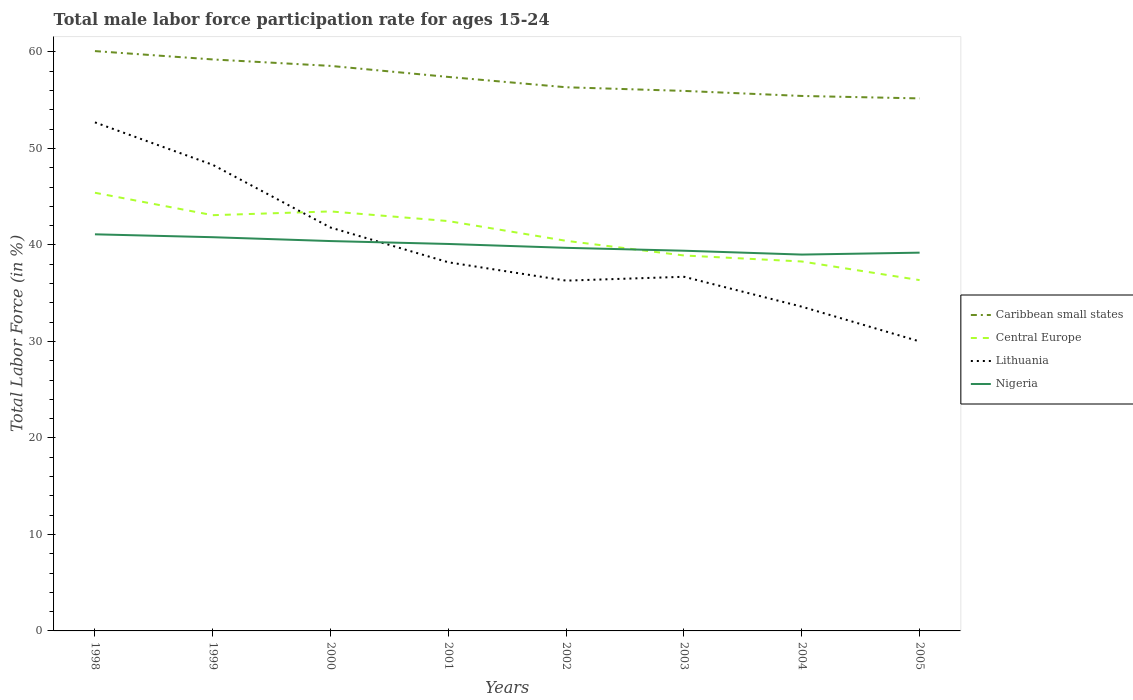Is the number of lines equal to the number of legend labels?
Offer a very short reply. Yes. Across all years, what is the maximum male labor force participation rate in Nigeria?
Your answer should be very brief. 39. In which year was the male labor force participation rate in Central Europe maximum?
Ensure brevity in your answer.  2005. What is the total male labor force participation rate in Caribbean small states in the graph?
Keep it short and to the point. 3.11. What is the difference between the highest and the second highest male labor force participation rate in Central Europe?
Keep it short and to the point. 9.05. Is the male labor force participation rate in Nigeria strictly greater than the male labor force participation rate in Central Europe over the years?
Keep it short and to the point. No. How many lines are there?
Your answer should be compact. 4. What is the difference between two consecutive major ticks on the Y-axis?
Offer a very short reply. 10. Does the graph contain any zero values?
Provide a short and direct response. No. Where does the legend appear in the graph?
Offer a terse response. Center right. What is the title of the graph?
Provide a succinct answer. Total male labor force participation rate for ages 15-24. Does "Rwanda" appear as one of the legend labels in the graph?
Offer a very short reply. No. What is the label or title of the X-axis?
Give a very brief answer. Years. What is the Total Labor Force (in %) of Caribbean small states in 1998?
Offer a very short reply. 60.09. What is the Total Labor Force (in %) in Central Europe in 1998?
Offer a very short reply. 45.41. What is the Total Labor Force (in %) of Lithuania in 1998?
Give a very brief answer. 52.7. What is the Total Labor Force (in %) of Nigeria in 1998?
Your answer should be very brief. 41.1. What is the Total Labor Force (in %) in Caribbean small states in 1999?
Provide a short and direct response. 59.22. What is the Total Labor Force (in %) in Central Europe in 1999?
Keep it short and to the point. 43.08. What is the Total Labor Force (in %) of Lithuania in 1999?
Offer a very short reply. 48.3. What is the Total Labor Force (in %) in Nigeria in 1999?
Your answer should be very brief. 40.8. What is the Total Labor Force (in %) of Caribbean small states in 2000?
Your answer should be very brief. 58.55. What is the Total Labor Force (in %) in Central Europe in 2000?
Make the answer very short. 43.47. What is the Total Labor Force (in %) in Lithuania in 2000?
Ensure brevity in your answer.  41.8. What is the Total Labor Force (in %) in Nigeria in 2000?
Make the answer very short. 40.4. What is the Total Labor Force (in %) in Caribbean small states in 2001?
Provide a short and direct response. 57.41. What is the Total Labor Force (in %) in Central Europe in 2001?
Give a very brief answer. 42.47. What is the Total Labor Force (in %) in Lithuania in 2001?
Offer a terse response. 38.2. What is the Total Labor Force (in %) of Nigeria in 2001?
Provide a succinct answer. 40.1. What is the Total Labor Force (in %) of Caribbean small states in 2002?
Your answer should be very brief. 56.34. What is the Total Labor Force (in %) in Central Europe in 2002?
Your answer should be very brief. 40.42. What is the Total Labor Force (in %) of Lithuania in 2002?
Provide a succinct answer. 36.3. What is the Total Labor Force (in %) in Nigeria in 2002?
Provide a succinct answer. 39.7. What is the Total Labor Force (in %) of Caribbean small states in 2003?
Provide a succinct answer. 55.96. What is the Total Labor Force (in %) in Central Europe in 2003?
Keep it short and to the point. 38.91. What is the Total Labor Force (in %) in Lithuania in 2003?
Offer a terse response. 36.7. What is the Total Labor Force (in %) of Nigeria in 2003?
Ensure brevity in your answer.  39.4. What is the Total Labor Force (in %) in Caribbean small states in 2004?
Make the answer very short. 55.44. What is the Total Labor Force (in %) of Central Europe in 2004?
Provide a succinct answer. 38.28. What is the Total Labor Force (in %) in Lithuania in 2004?
Give a very brief answer. 33.6. What is the Total Labor Force (in %) of Caribbean small states in 2005?
Make the answer very short. 55.18. What is the Total Labor Force (in %) in Central Europe in 2005?
Offer a terse response. 36.35. What is the Total Labor Force (in %) of Nigeria in 2005?
Ensure brevity in your answer.  39.2. Across all years, what is the maximum Total Labor Force (in %) in Caribbean small states?
Offer a very short reply. 60.09. Across all years, what is the maximum Total Labor Force (in %) of Central Europe?
Offer a very short reply. 45.41. Across all years, what is the maximum Total Labor Force (in %) of Lithuania?
Make the answer very short. 52.7. Across all years, what is the maximum Total Labor Force (in %) of Nigeria?
Your response must be concise. 41.1. Across all years, what is the minimum Total Labor Force (in %) in Caribbean small states?
Keep it short and to the point. 55.18. Across all years, what is the minimum Total Labor Force (in %) in Central Europe?
Offer a very short reply. 36.35. Across all years, what is the minimum Total Labor Force (in %) in Nigeria?
Your answer should be very brief. 39. What is the total Total Labor Force (in %) in Caribbean small states in the graph?
Provide a succinct answer. 458.19. What is the total Total Labor Force (in %) in Central Europe in the graph?
Provide a short and direct response. 328.4. What is the total Total Labor Force (in %) in Lithuania in the graph?
Offer a terse response. 317.6. What is the total Total Labor Force (in %) of Nigeria in the graph?
Make the answer very short. 319.7. What is the difference between the Total Labor Force (in %) in Caribbean small states in 1998 and that in 1999?
Provide a short and direct response. 0.87. What is the difference between the Total Labor Force (in %) of Central Europe in 1998 and that in 1999?
Ensure brevity in your answer.  2.32. What is the difference between the Total Labor Force (in %) in Caribbean small states in 1998 and that in 2000?
Your response must be concise. 1.53. What is the difference between the Total Labor Force (in %) in Central Europe in 1998 and that in 2000?
Offer a terse response. 1.93. What is the difference between the Total Labor Force (in %) in Lithuania in 1998 and that in 2000?
Offer a terse response. 10.9. What is the difference between the Total Labor Force (in %) of Nigeria in 1998 and that in 2000?
Offer a very short reply. 0.7. What is the difference between the Total Labor Force (in %) of Caribbean small states in 1998 and that in 2001?
Make the answer very short. 2.68. What is the difference between the Total Labor Force (in %) of Central Europe in 1998 and that in 2001?
Ensure brevity in your answer.  2.94. What is the difference between the Total Labor Force (in %) in Nigeria in 1998 and that in 2001?
Provide a short and direct response. 1. What is the difference between the Total Labor Force (in %) in Caribbean small states in 1998 and that in 2002?
Give a very brief answer. 3.75. What is the difference between the Total Labor Force (in %) in Central Europe in 1998 and that in 2002?
Offer a terse response. 4.98. What is the difference between the Total Labor Force (in %) in Caribbean small states in 1998 and that in 2003?
Ensure brevity in your answer.  4.13. What is the difference between the Total Labor Force (in %) in Central Europe in 1998 and that in 2003?
Offer a very short reply. 6.5. What is the difference between the Total Labor Force (in %) of Caribbean small states in 1998 and that in 2004?
Provide a short and direct response. 4.65. What is the difference between the Total Labor Force (in %) in Central Europe in 1998 and that in 2004?
Provide a short and direct response. 7.12. What is the difference between the Total Labor Force (in %) of Caribbean small states in 1998 and that in 2005?
Make the answer very short. 4.9. What is the difference between the Total Labor Force (in %) of Central Europe in 1998 and that in 2005?
Your answer should be compact. 9.05. What is the difference between the Total Labor Force (in %) of Lithuania in 1998 and that in 2005?
Provide a succinct answer. 22.7. What is the difference between the Total Labor Force (in %) in Caribbean small states in 1999 and that in 2000?
Offer a very short reply. 0.67. What is the difference between the Total Labor Force (in %) in Central Europe in 1999 and that in 2000?
Your response must be concise. -0.39. What is the difference between the Total Labor Force (in %) of Lithuania in 1999 and that in 2000?
Your response must be concise. 6.5. What is the difference between the Total Labor Force (in %) of Nigeria in 1999 and that in 2000?
Provide a short and direct response. 0.4. What is the difference between the Total Labor Force (in %) in Caribbean small states in 1999 and that in 2001?
Your answer should be very brief. 1.81. What is the difference between the Total Labor Force (in %) in Central Europe in 1999 and that in 2001?
Offer a terse response. 0.61. What is the difference between the Total Labor Force (in %) of Caribbean small states in 1999 and that in 2002?
Make the answer very short. 2.88. What is the difference between the Total Labor Force (in %) in Central Europe in 1999 and that in 2002?
Your answer should be very brief. 2.66. What is the difference between the Total Labor Force (in %) in Nigeria in 1999 and that in 2002?
Your response must be concise. 1.1. What is the difference between the Total Labor Force (in %) in Caribbean small states in 1999 and that in 2003?
Your response must be concise. 3.26. What is the difference between the Total Labor Force (in %) in Central Europe in 1999 and that in 2003?
Provide a succinct answer. 4.18. What is the difference between the Total Labor Force (in %) in Lithuania in 1999 and that in 2003?
Offer a very short reply. 11.6. What is the difference between the Total Labor Force (in %) in Caribbean small states in 1999 and that in 2004?
Provide a short and direct response. 3.78. What is the difference between the Total Labor Force (in %) in Central Europe in 1999 and that in 2004?
Offer a terse response. 4.8. What is the difference between the Total Labor Force (in %) of Lithuania in 1999 and that in 2004?
Provide a short and direct response. 14.7. What is the difference between the Total Labor Force (in %) of Caribbean small states in 1999 and that in 2005?
Keep it short and to the point. 4.04. What is the difference between the Total Labor Force (in %) of Central Europe in 1999 and that in 2005?
Provide a short and direct response. 6.73. What is the difference between the Total Labor Force (in %) in Lithuania in 1999 and that in 2005?
Make the answer very short. 18.3. What is the difference between the Total Labor Force (in %) of Nigeria in 1999 and that in 2005?
Your answer should be compact. 1.6. What is the difference between the Total Labor Force (in %) in Caribbean small states in 2000 and that in 2001?
Give a very brief answer. 1.14. What is the difference between the Total Labor Force (in %) in Nigeria in 2000 and that in 2001?
Give a very brief answer. 0.3. What is the difference between the Total Labor Force (in %) of Caribbean small states in 2000 and that in 2002?
Your answer should be very brief. 2.21. What is the difference between the Total Labor Force (in %) of Central Europe in 2000 and that in 2002?
Make the answer very short. 3.05. What is the difference between the Total Labor Force (in %) in Lithuania in 2000 and that in 2002?
Provide a short and direct response. 5.5. What is the difference between the Total Labor Force (in %) in Nigeria in 2000 and that in 2002?
Provide a succinct answer. 0.7. What is the difference between the Total Labor Force (in %) in Caribbean small states in 2000 and that in 2003?
Your answer should be very brief. 2.59. What is the difference between the Total Labor Force (in %) in Central Europe in 2000 and that in 2003?
Keep it short and to the point. 4.57. What is the difference between the Total Labor Force (in %) in Lithuania in 2000 and that in 2003?
Your response must be concise. 5.1. What is the difference between the Total Labor Force (in %) of Caribbean small states in 2000 and that in 2004?
Offer a terse response. 3.11. What is the difference between the Total Labor Force (in %) of Central Europe in 2000 and that in 2004?
Provide a succinct answer. 5.19. What is the difference between the Total Labor Force (in %) in Lithuania in 2000 and that in 2004?
Your answer should be compact. 8.2. What is the difference between the Total Labor Force (in %) of Caribbean small states in 2000 and that in 2005?
Offer a terse response. 3.37. What is the difference between the Total Labor Force (in %) of Central Europe in 2000 and that in 2005?
Ensure brevity in your answer.  7.12. What is the difference between the Total Labor Force (in %) of Lithuania in 2000 and that in 2005?
Your answer should be very brief. 11.8. What is the difference between the Total Labor Force (in %) of Nigeria in 2000 and that in 2005?
Offer a very short reply. 1.2. What is the difference between the Total Labor Force (in %) in Caribbean small states in 2001 and that in 2002?
Make the answer very short. 1.07. What is the difference between the Total Labor Force (in %) in Central Europe in 2001 and that in 2002?
Offer a terse response. 2.05. What is the difference between the Total Labor Force (in %) of Lithuania in 2001 and that in 2002?
Provide a succinct answer. 1.9. What is the difference between the Total Labor Force (in %) in Caribbean small states in 2001 and that in 2003?
Ensure brevity in your answer.  1.45. What is the difference between the Total Labor Force (in %) of Central Europe in 2001 and that in 2003?
Your answer should be very brief. 3.56. What is the difference between the Total Labor Force (in %) of Nigeria in 2001 and that in 2003?
Provide a succinct answer. 0.7. What is the difference between the Total Labor Force (in %) of Caribbean small states in 2001 and that in 2004?
Offer a very short reply. 1.97. What is the difference between the Total Labor Force (in %) of Central Europe in 2001 and that in 2004?
Keep it short and to the point. 4.19. What is the difference between the Total Labor Force (in %) in Lithuania in 2001 and that in 2004?
Ensure brevity in your answer.  4.6. What is the difference between the Total Labor Force (in %) in Nigeria in 2001 and that in 2004?
Make the answer very short. 1.1. What is the difference between the Total Labor Force (in %) of Caribbean small states in 2001 and that in 2005?
Give a very brief answer. 2.22. What is the difference between the Total Labor Force (in %) in Central Europe in 2001 and that in 2005?
Offer a very short reply. 6.12. What is the difference between the Total Labor Force (in %) of Caribbean small states in 2002 and that in 2003?
Your answer should be very brief. 0.38. What is the difference between the Total Labor Force (in %) of Central Europe in 2002 and that in 2003?
Provide a succinct answer. 1.52. What is the difference between the Total Labor Force (in %) in Nigeria in 2002 and that in 2003?
Keep it short and to the point. 0.3. What is the difference between the Total Labor Force (in %) of Caribbean small states in 2002 and that in 2004?
Ensure brevity in your answer.  0.9. What is the difference between the Total Labor Force (in %) in Central Europe in 2002 and that in 2004?
Give a very brief answer. 2.14. What is the difference between the Total Labor Force (in %) in Lithuania in 2002 and that in 2004?
Give a very brief answer. 2.7. What is the difference between the Total Labor Force (in %) in Nigeria in 2002 and that in 2004?
Give a very brief answer. 0.7. What is the difference between the Total Labor Force (in %) in Caribbean small states in 2002 and that in 2005?
Ensure brevity in your answer.  1.15. What is the difference between the Total Labor Force (in %) in Central Europe in 2002 and that in 2005?
Offer a terse response. 4.07. What is the difference between the Total Labor Force (in %) of Lithuania in 2002 and that in 2005?
Offer a very short reply. 6.3. What is the difference between the Total Labor Force (in %) in Caribbean small states in 2003 and that in 2004?
Ensure brevity in your answer.  0.52. What is the difference between the Total Labor Force (in %) of Central Europe in 2003 and that in 2004?
Provide a short and direct response. 0.62. What is the difference between the Total Labor Force (in %) in Lithuania in 2003 and that in 2004?
Give a very brief answer. 3.1. What is the difference between the Total Labor Force (in %) in Caribbean small states in 2003 and that in 2005?
Your answer should be very brief. 0.78. What is the difference between the Total Labor Force (in %) in Central Europe in 2003 and that in 2005?
Keep it short and to the point. 2.55. What is the difference between the Total Labor Force (in %) of Lithuania in 2003 and that in 2005?
Provide a succinct answer. 6.7. What is the difference between the Total Labor Force (in %) of Caribbean small states in 2004 and that in 2005?
Keep it short and to the point. 0.25. What is the difference between the Total Labor Force (in %) of Central Europe in 2004 and that in 2005?
Make the answer very short. 1.93. What is the difference between the Total Labor Force (in %) of Nigeria in 2004 and that in 2005?
Your answer should be very brief. -0.2. What is the difference between the Total Labor Force (in %) of Caribbean small states in 1998 and the Total Labor Force (in %) of Central Europe in 1999?
Keep it short and to the point. 17. What is the difference between the Total Labor Force (in %) in Caribbean small states in 1998 and the Total Labor Force (in %) in Lithuania in 1999?
Your answer should be compact. 11.79. What is the difference between the Total Labor Force (in %) of Caribbean small states in 1998 and the Total Labor Force (in %) of Nigeria in 1999?
Your answer should be compact. 19.29. What is the difference between the Total Labor Force (in %) of Central Europe in 1998 and the Total Labor Force (in %) of Lithuania in 1999?
Ensure brevity in your answer.  -2.89. What is the difference between the Total Labor Force (in %) in Central Europe in 1998 and the Total Labor Force (in %) in Nigeria in 1999?
Your answer should be very brief. 4.61. What is the difference between the Total Labor Force (in %) in Caribbean small states in 1998 and the Total Labor Force (in %) in Central Europe in 2000?
Provide a succinct answer. 16.61. What is the difference between the Total Labor Force (in %) in Caribbean small states in 1998 and the Total Labor Force (in %) in Lithuania in 2000?
Provide a short and direct response. 18.29. What is the difference between the Total Labor Force (in %) in Caribbean small states in 1998 and the Total Labor Force (in %) in Nigeria in 2000?
Your answer should be compact. 19.69. What is the difference between the Total Labor Force (in %) of Central Europe in 1998 and the Total Labor Force (in %) of Lithuania in 2000?
Ensure brevity in your answer.  3.61. What is the difference between the Total Labor Force (in %) of Central Europe in 1998 and the Total Labor Force (in %) of Nigeria in 2000?
Offer a very short reply. 5.01. What is the difference between the Total Labor Force (in %) in Lithuania in 1998 and the Total Labor Force (in %) in Nigeria in 2000?
Provide a short and direct response. 12.3. What is the difference between the Total Labor Force (in %) of Caribbean small states in 1998 and the Total Labor Force (in %) of Central Europe in 2001?
Make the answer very short. 17.62. What is the difference between the Total Labor Force (in %) of Caribbean small states in 1998 and the Total Labor Force (in %) of Lithuania in 2001?
Make the answer very short. 21.89. What is the difference between the Total Labor Force (in %) of Caribbean small states in 1998 and the Total Labor Force (in %) of Nigeria in 2001?
Your answer should be very brief. 19.99. What is the difference between the Total Labor Force (in %) of Central Europe in 1998 and the Total Labor Force (in %) of Lithuania in 2001?
Your answer should be compact. 7.21. What is the difference between the Total Labor Force (in %) in Central Europe in 1998 and the Total Labor Force (in %) in Nigeria in 2001?
Give a very brief answer. 5.31. What is the difference between the Total Labor Force (in %) of Caribbean small states in 1998 and the Total Labor Force (in %) of Central Europe in 2002?
Your response must be concise. 19.66. What is the difference between the Total Labor Force (in %) of Caribbean small states in 1998 and the Total Labor Force (in %) of Lithuania in 2002?
Provide a short and direct response. 23.79. What is the difference between the Total Labor Force (in %) of Caribbean small states in 1998 and the Total Labor Force (in %) of Nigeria in 2002?
Ensure brevity in your answer.  20.39. What is the difference between the Total Labor Force (in %) in Central Europe in 1998 and the Total Labor Force (in %) in Lithuania in 2002?
Offer a very short reply. 9.11. What is the difference between the Total Labor Force (in %) in Central Europe in 1998 and the Total Labor Force (in %) in Nigeria in 2002?
Provide a succinct answer. 5.71. What is the difference between the Total Labor Force (in %) of Caribbean small states in 1998 and the Total Labor Force (in %) of Central Europe in 2003?
Provide a short and direct response. 21.18. What is the difference between the Total Labor Force (in %) of Caribbean small states in 1998 and the Total Labor Force (in %) of Lithuania in 2003?
Your answer should be very brief. 23.39. What is the difference between the Total Labor Force (in %) in Caribbean small states in 1998 and the Total Labor Force (in %) in Nigeria in 2003?
Ensure brevity in your answer.  20.69. What is the difference between the Total Labor Force (in %) of Central Europe in 1998 and the Total Labor Force (in %) of Lithuania in 2003?
Provide a succinct answer. 8.71. What is the difference between the Total Labor Force (in %) in Central Europe in 1998 and the Total Labor Force (in %) in Nigeria in 2003?
Offer a very short reply. 6.01. What is the difference between the Total Labor Force (in %) in Caribbean small states in 1998 and the Total Labor Force (in %) in Central Europe in 2004?
Provide a succinct answer. 21.8. What is the difference between the Total Labor Force (in %) in Caribbean small states in 1998 and the Total Labor Force (in %) in Lithuania in 2004?
Your response must be concise. 26.49. What is the difference between the Total Labor Force (in %) in Caribbean small states in 1998 and the Total Labor Force (in %) in Nigeria in 2004?
Make the answer very short. 21.09. What is the difference between the Total Labor Force (in %) of Central Europe in 1998 and the Total Labor Force (in %) of Lithuania in 2004?
Your answer should be very brief. 11.81. What is the difference between the Total Labor Force (in %) of Central Europe in 1998 and the Total Labor Force (in %) of Nigeria in 2004?
Offer a very short reply. 6.41. What is the difference between the Total Labor Force (in %) of Lithuania in 1998 and the Total Labor Force (in %) of Nigeria in 2004?
Give a very brief answer. 13.7. What is the difference between the Total Labor Force (in %) of Caribbean small states in 1998 and the Total Labor Force (in %) of Central Europe in 2005?
Offer a very short reply. 23.73. What is the difference between the Total Labor Force (in %) of Caribbean small states in 1998 and the Total Labor Force (in %) of Lithuania in 2005?
Your response must be concise. 30.09. What is the difference between the Total Labor Force (in %) in Caribbean small states in 1998 and the Total Labor Force (in %) in Nigeria in 2005?
Your answer should be compact. 20.89. What is the difference between the Total Labor Force (in %) in Central Europe in 1998 and the Total Labor Force (in %) in Lithuania in 2005?
Offer a terse response. 15.41. What is the difference between the Total Labor Force (in %) of Central Europe in 1998 and the Total Labor Force (in %) of Nigeria in 2005?
Offer a very short reply. 6.21. What is the difference between the Total Labor Force (in %) of Caribbean small states in 1999 and the Total Labor Force (in %) of Central Europe in 2000?
Provide a short and direct response. 15.75. What is the difference between the Total Labor Force (in %) of Caribbean small states in 1999 and the Total Labor Force (in %) of Lithuania in 2000?
Ensure brevity in your answer.  17.42. What is the difference between the Total Labor Force (in %) of Caribbean small states in 1999 and the Total Labor Force (in %) of Nigeria in 2000?
Your response must be concise. 18.82. What is the difference between the Total Labor Force (in %) of Central Europe in 1999 and the Total Labor Force (in %) of Lithuania in 2000?
Give a very brief answer. 1.28. What is the difference between the Total Labor Force (in %) of Central Europe in 1999 and the Total Labor Force (in %) of Nigeria in 2000?
Make the answer very short. 2.68. What is the difference between the Total Labor Force (in %) in Lithuania in 1999 and the Total Labor Force (in %) in Nigeria in 2000?
Your answer should be very brief. 7.9. What is the difference between the Total Labor Force (in %) of Caribbean small states in 1999 and the Total Labor Force (in %) of Central Europe in 2001?
Offer a terse response. 16.75. What is the difference between the Total Labor Force (in %) of Caribbean small states in 1999 and the Total Labor Force (in %) of Lithuania in 2001?
Keep it short and to the point. 21.02. What is the difference between the Total Labor Force (in %) in Caribbean small states in 1999 and the Total Labor Force (in %) in Nigeria in 2001?
Offer a very short reply. 19.12. What is the difference between the Total Labor Force (in %) in Central Europe in 1999 and the Total Labor Force (in %) in Lithuania in 2001?
Offer a very short reply. 4.88. What is the difference between the Total Labor Force (in %) in Central Europe in 1999 and the Total Labor Force (in %) in Nigeria in 2001?
Your answer should be very brief. 2.98. What is the difference between the Total Labor Force (in %) of Lithuania in 1999 and the Total Labor Force (in %) of Nigeria in 2001?
Provide a succinct answer. 8.2. What is the difference between the Total Labor Force (in %) in Caribbean small states in 1999 and the Total Labor Force (in %) in Central Europe in 2002?
Offer a very short reply. 18.8. What is the difference between the Total Labor Force (in %) of Caribbean small states in 1999 and the Total Labor Force (in %) of Lithuania in 2002?
Your answer should be compact. 22.92. What is the difference between the Total Labor Force (in %) of Caribbean small states in 1999 and the Total Labor Force (in %) of Nigeria in 2002?
Provide a succinct answer. 19.52. What is the difference between the Total Labor Force (in %) of Central Europe in 1999 and the Total Labor Force (in %) of Lithuania in 2002?
Ensure brevity in your answer.  6.78. What is the difference between the Total Labor Force (in %) in Central Europe in 1999 and the Total Labor Force (in %) in Nigeria in 2002?
Make the answer very short. 3.38. What is the difference between the Total Labor Force (in %) in Caribbean small states in 1999 and the Total Labor Force (in %) in Central Europe in 2003?
Keep it short and to the point. 20.32. What is the difference between the Total Labor Force (in %) of Caribbean small states in 1999 and the Total Labor Force (in %) of Lithuania in 2003?
Provide a succinct answer. 22.52. What is the difference between the Total Labor Force (in %) of Caribbean small states in 1999 and the Total Labor Force (in %) of Nigeria in 2003?
Provide a short and direct response. 19.82. What is the difference between the Total Labor Force (in %) in Central Europe in 1999 and the Total Labor Force (in %) in Lithuania in 2003?
Offer a very short reply. 6.38. What is the difference between the Total Labor Force (in %) of Central Europe in 1999 and the Total Labor Force (in %) of Nigeria in 2003?
Give a very brief answer. 3.68. What is the difference between the Total Labor Force (in %) of Caribbean small states in 1999 and the Total Labor Force (in %) of Central Europe in 2004?
Your response must be concise. 20.94. What is the difference between the Total Labor Force (in %) of Caribbean small states in 1999 and the Total Labor Force (in %) of Lithuania in 2004?
Keep it short and to the point. 25.62. What is the difference between the Total Labor Force (in %) of Caribbean small states in 1999 and the Total Labor Force (in %) of Nigeria in 2004?
Give a very brief answer. 20.22. What is the difference between the Total Labor Force (in %) in Central Europe in 1999 and the Total Labor Force (in %) in Lithuania in 2004?
Offer a terse response. 9.48. What is the difference between the Total Labor Force (in %) of Central Europe in 1999 and the Total Labor Force (in %) of Nigeria in 2004?
Provide a short and direct response. 4.08. What is the difference between the Total Labor Force (in %) of Caribbean small states in 1999 and the Total Labor Force (in %) of Central Europe in 2005?
Keep it short and to the point. 22.87. What is the difference between the Total Labor Force (in %) in Caribbean small states in 1999 and the Total Labor Force (in %) in Lithuania in 2005?
Provide a succinct answer. 29.22. What is the difference between the Total Labor Force (in %) in Caribbean small states in 1999 and the Total Labor Force (in %) in Nigeria in 2005?
Make the answer very short. 20.02. What is the difference between the Total Labor Force (in %) of Central Europe in 1999 and the Total Labor Force (in %) of Lithuania in 2005?
Your response must be concise. 13.08. What is the difference between the Total Labor Force (in %) in Central Europe in 1999 and the Total Labor Force (in %) in Nigeria in 2005?
Give a very brief answer. 3.88. What is the difference between the Total Labor Force (in %) in Caribbean small states in 2000 and the Total Labor Force (in %) in Central Europe in 2001?
Your response must be concise. 16.08. What is the difference between the Total Labor Force (in %) of Caribbean small states in 2000 and the Total Labor Force (in %) of Lithuania in 2001?
Provide a succinct answer. 20.35. What is the difference between the Total Labor Force (in %) in Caribbean small states in 2000 and the Total Labor Force (in %) in Nigeria in 2001?
Your response must be concise. 18.45. What is the difference between the Total Labor Force (in %) of Central Europe in 2000 and the Total Labor Force (in %) of Lithuania in 2001?
Ensure brevity in your answer.  5.27. What is the difference between the Total Labor Force (in %) of Central Europe in 2000 and the Total Labor Force (in %) of Nigeria in 2001?
Give a very brief answer. 3.37. What is the difference between the Total Labor Force (in %) in Caribbean small states in 2000 and the Total Labor Force (in %) in Central Europe in 2002?
Offer a very short reply. 18.13. What is the difference between the Total Labor Force (in %) of Caribbean small states in 2000 and the Total Labor Force (in %) of Lithuania in 2002?
Ensure brevity in your answer.  22.25. What is the difference between the Total Labor Force (in %) of Caribbean small states in 2000 and the Total Labor Force (in %) of Nigeria in 2002?
Give a very brief answer. 18.85. What is the difference between the Total Labor Force (in %) of Central Europe in 2000 and the Total Labor Force (in %) of Lithuania in 2002?
Your answer should be very brief. 7.17. What is the difference between the Total Labor Force (in %) in Central Europe in 2000 and the Total Labor Force (in %) in Nigeria in 2002?
Your response must be concise. 3.77. What is the difference between the Total Labor Force (in %) in Lithuania in 2000 and the Total Labor Force (in %) in Nigeria in 2002?
Your answer should be very brief. 2.1. What is the difference between the Total Labor Force (in %) of Caribbean small states in 2000 and the Total Labor Force (in %) of Central Europe in 2003?
Make the answer very short. 19.65. What is the difference between the Total Labor Force (in %) in Caribbean small states in 2000 and the Total Labor Force (in %) in Lithuania in 2003?
Your answer should be very brief. 21.85. What is the difference between the Total Labor Force (in %) in Caribbean small states in 2000 and the Total Labor Force (in %) in Nigeria in 2003?
Provide a succinct answer. 19.15. What is the difference between the Total Labor Force (in %) of Central Europe in 2000 and the Total Labor Force (in %) of Lithuania in 2003?
Your answer should be compact. 6.77. What is the difference between the Total Labor Force (in %) of Central Europe in 2000 and the Total Labor Force (in %) of Nigeria in 2003?
Give a very brief answer. 4.07. What is the difference between the Total Labor Force (in %) of Lithuania in 2000 and the Total Labor Force (in %) of Nigeria in 2003?
Your answer should be compact. 2.4. What is the difference between the Total Labor Force (in %) of Caribbean small states in 2000 and the Total Labor Force (in %) of Central Europe in 2004?
Your answer should be very brief. 20.27. What is the difference between the Total Labor Force (in %) of Caribbean small states in 2000 and the Total Labor Force (in %) of Lithuania in 2004?
Make the answer very short. 24.95. What is the difference between the Total Labor Force (in %) in Caribbean small states in 2000 and the Total Labor Force (in %) in Nigeria in 2004?
Ensure brevity in your answer.  19.55. What is the difference between the Total Labor Force (in %) of Central Europe in 2000 and the Total Labor Force (in %) of Lithuania in 2004?
Your answer should be very brief. 9.87. What is the difference between the Total Labor Force (in %) of Central Europe in 2000 and the Total Labor Force (in %) of Nigeria in 2004?
Offer a very short reply. 4.47. What is the difference between the Total Labor Force (in %) in Caribbean small states in 2000 and the Total Labor Force (in %) in Central Europe in 2005?
Provide a short and direct response. 22.2. What is the difference between the Total Labor Force (in %) of Caribbean small states in 2000 and the Total Labor Force (in %) of Lithuania in 2005?
Your answer should be very brief. 28.55. What is the difference between the Total Labor Force (in %) of Caribbean small states in 2000 and the Total Labor Force (in %) of Nigeria in 2005?
Offer a terse response. 19.35. What is the difference between the Total Labor Force (in %) of Central Europe in 2000 and the Total Labor Force (in %) of Lithuania in 2005?
Your response must be concise. 13.47. What is the difference between the Total Labor Force (in %) in Central Europe in 2000 and the Total Labor Force (in %) in Nigeria in 2005?
Provide a short and direct response. 4.27. What is the difference between the Total Labor Force (in %) of Lithuania in 2000 and the Total Labor Force (in %) of Nigeria in 2005?
Your answer should be very brief. 2.6. What is the difference between the Total Labor Force (in %) of Caribbean small states in 2001 and the Total Labor Force (in %) of Central Europe in 2002?
Give a very brief answer. 16.98. What is the difference between the Total Labor Force (in %) of Caribbean small states in 2001 and the Total Labor Force (in %) of Lithuania in 2002?
Your answer should be very brief. 21.11. What is the difference between the Total Labor Force (in %) of Caribbean small states in 2001 and the Total Labor Force (in %) of Nigeria in 2002?
Your answer should be compact. 17.71. What is the difference between the Total Labor Force (in %) of Central Europe in 2001 and the Total Labor Force (in %) of Lithuania in 2002?
Keep it short and to the point. 6.17. What is the difference between the Total Labor Force (in %) of Central Europe in 2001 and the Total Labor Force (in %) of Nigeria in 2002?
Give a very brief answer. 2.77. What is the difference between the Total Labor Force (in %) of Lithuania in 2001 and the Total Labor Force (in %) of Nigeria in 2002?
Your answer should be very brief. -1.5. What is the difference between the Total Labor Force (in %) in Caribbean small states in 2001 and the Total Labor Force (in %) in Central Europe in 2003?
Your response must be concise. 18.5. What is the difference between the Total Labor Force (in %) of Caribbean small states in 2001 and the Total Labor Force (in %) of Lithuania in 2003?
Offer a very short reply. 20.71. What is the difference between the Total Labor Force (in %) in Caribbean small states in 2001 and the Total Labor Force (in %) in Nigeria in 2003?
Your answer should be compact. 18.01. What is the difference between the Total Labor Force (in %) in Central Europe in 2001 and the Total Labor Force (in %) in Lithuania in 2003?
Your response must be concise. 5.77. What is the difference between the Total Labor Force (in %) of Central Europe in 2001 and the Total Labor Force (in %) of Nigeria in 2003?
Make the answer very short. 3.07. What is the difference between the Total Labor Force (in %) in Caribbean small states in 2001 and the Total Labor Force (in %) in Central Europe in 2004?
Provide a short and direct response. 19.12. What is the difference between the Total Labor Force (in %) of Caribbean small states in 2001 and the Total Labor Force (in %) of Lithuania in 2004?
Offer a terse response. 23.81. What is the difference between the Total Labor Force (in %) of Caribbean small states in 2001 and the Total Labor Force (in %) of Nigeria in 2004?
Provide a succinct answer. 18.41. What is the difference between the Total Labor Force (in %) of Central Europe in 2001 and the Total Labor Force (in %) of Lithuania in 2004?
Offer a very short reply. 8.87. What is the difference between the Total Labor Force (in %) of Central Europe in 2001 and the Total Labor Force (in %) of Nigeria in 2004?
Your response must be concise. 3.47. What is the difference between the Total Labor Force (in %) in Caribbean small states in 2001 and the Total Labor Force (in %) in Central Europe in 2005?
Provide a short and direct response. 21.05. What is the difference between the Total Labor Force (in %) in Caribbean small states in 2001 and the Total Labor Force (in %) in Lithuania in 2005?
Keep it short and to the point. 27.41. What is the difference between the Total Labor Force (in %) in Caribbean small states in 2001 and the Total Labor Force (in %) in Nigeria in 2005?
Provide a succinct answer. 18.21. What is the difference between the Total Labor Force (in %) of Central Europe in 2001 and the Total Labor Force (in %) of Lithuania in 2005?
Give a very brief answer. 12.47. What is the difference between the Total Labor Force (in %) in Central Europe in 2001 and the Total Labor Force (in %) in Nigeria in 2005?
Provide a short and direct response. 3.27. What is the difference between the Total Labor Force (in %) of Caribbean small states in 2002 and the Total Labor Force (in %) of Central Europe in 2003?
Your answer should be very brief. 17.43. What is the difference between the Total Labor Force (in %) in Caribbean small states in 2002 and the Total Labor Force (in %) in Lithuania in 2003?
Keep it short and to the point. 19.64. What is the difference between the Total Labor Force (in %) in Caribbean small states in 2002 and the Total Labor Force (in %) in Nigeria in 2003?
Make the answer very short. 16.94. What is the difference between the Total Labor Force (in %) in Central Europe in 2002 and the Total Labor Force (in %) in Lithuania in 2003?
Provide a short and direct response. 3.72. What is the difference between the Total Labor Force (in %) of Lithuania in 2002 and the Total Labor Force (in %) of Nigeria in 2003?
Make the answer very short. -3.1. What is the difference between the Total Labor Force (in %) in Caribbean small states in 2002 and the Total Labor Force (in %) in Central Europe in 2004?
Provide a succinct answer. 18.05. What is the difference between the Total Labor Force (in %) in Caribbean small states in 2002 and the Total Labor Force (in %) in Lithuania in 2004?
Give a very brief answer. 22.74. What is the difference between the Total Labor Force (in %) in Caribbean small states in 2002 and the Total Labor Force (in %) in Nigeria in 2004?
Provide a succinct answer. 17.34. What is the difference between the Total Labor Force (in %) in Central Europe in 2002 and the Total Labor Force (in %) in Lithuania in 2004?
Your answer should be compact. 6.82. What is the difference between the Total Labor Force (in %) in Central Europe in 2002 and the Total Labor Force (in %) in Nigeria in 2004?
Ensure brevity in your answer.  1.42. What is the difference between the Total Labor Force (in %) of Lithuania in 2002 and the Total Labor Force (in %) of Nigeria in 2004?
Your answer should be very brief. -2.7. What is the difference between the Total Labor Force (in %) in Caribbean small states in 2002 and the Total Labor Force (in %) in Central Europe in 2005?
Keep it short and to the point. 19.98. What is the difference between the Total Labor Force (in %) of Caribbean small states in 2002 and the Total Labor Force (in %) of Lithuania in 2005?
Offer a terse response. 26.34. What is the difference between the Total Labor Force (in %) of Caribbean small states in 2002 and the Total Labor Force (in %) of Nigeria in 2005?
Make the answer very short. 17.14. What is the difference between the Total Labor Force (in %) in Central Europe in 2002 and the Total Labor Force (in %) in Lithuania in 2005?
Your answer should be compact. 10.42. What is the difference between the Total Labor Force (in %) of Central Europe in 2002 and the Total Labor Force (in %) of Nigeria in 2005?
Keep it short and to the point. 1.22. What is the difference between the Total Labor Force (in %) in Lithuania in 2002 and the Total Labor Force (in %) in Nigeria in 2005?
Provide a succinct answer. -2.9. What is the difference between the Total Labor Force (in %) of Caribbean small states in 2003 and the Total Labor Force (in %) of Central Europe in 2004?
Your response must be concise. 17.68. What is the difference between the Total Labor Force (in %) in Caribbean small states in 2003 and the Total Labor Force (in %) in Lithuania in 2004?
Your answer should be compact. 22.36. What is the difference between the Total Labor Force (in %) of Caribbean small states in 2003 and the Total Labor Force (in %) of Nigeria in 2004?
Your answer should be compact. 16.96. What is the difference between the Total Labor Force (in %) of Central Europe in 2003 and the Total Labor Force (in %) of Lithuania in 2004?
Give a very brief answer. 5.31. What is the difference between the Total Labor Force (in %) of Central Europe in 2003 and the Total Labor Force (in %) of Nigeria in 2004?
Your answer should be compact. -0.09. What is the difference between the Total Labor Force (in %) in Caribbean small states in 2003 and the Total Labor Force (in %) in Central Europe in 2005?
Ensure brevity in your answer.  19.61. What is the difference between the Total Labor Force (in %) in Caribbean small states in 2003 and the Total Labor Force (in %) in Lithuania in 2005?
Your answer should be compact. 25.96. What is the difference between the Total Labor Force (in %) of Caribbean small states in 2003 and the Total Labor Force (in %) of Nigeria in 2005?
Your answer should be compact. 16.76. What is the difference between the Total Labor Force (in %) in Central Europe in 2003 and the Total Labor Force (in %) in Lithuania in 2005?
Offer a terse response. 8.91. What is the difference between the Total Labor Force (in %) of Central Europe in 2003 and the Total Labor Force (in %) of Nigeria in 2005?
Keep it short and to the point. -0.29. What is the difference between the Total Labor Force (in %) of Lithuania in 2003 and the Total Labor Force (in %) of Nigeria in 2005?
Provide a short and direct response. -2.5. What is the difference between the Total Labor Force (in %) in Caribbean small states in 2004 and the Total Labor Force (in %) in Central Europe in 2005?
Give a very brief answer. 19.08. What is the difference between the Total Labor Force (in %) of Caribbean small states in 2004 and the Total Labor Force (in %) of Lithuania in 2005?
Provide a short and direct response. 25.44. What is the difference between the Total Labor Force (in %) in Caribbean small states in 2004 and the Total Labor Force (in %) in Nigeria in 2005?
Give a very brief answer. 16.24. What is the difference between the Total Labor Force (in %) of Central Europe in 2004 and the Total Labor Force (in %) of Lithuania in 2005?
Provide a short and direct response. 8.28. What is the difference between the Total Labor Force (in %) of Central Europe in 2004 and the Total Labor Force (in %) of Nigeria in 2005?
Your response must be concise. -0.92. What is the difference between the Total Labor Force (in %) of Lithuania in 2004 and the Total Labor Force (in %) of Nigeria in 2005?
Your answer should be compact. -5.6. What is the average Total Labor Force (in %) of Caribbean small states per year?
Keep it short and to the point. 57.27. What is the average Total Labor Force (in %) in Central Europe per year?
Your answer should be compact. 41.05. What is the average Total Labor Force (in %) in Lithuania per year?
Offer a terse response. 39.7. What is the average Total Labor Force (in %) in Nigeria per year?
Your answer should be very brief. 39.96. In the year 1998, what is the difference between the Total Labor Force (in %) in Caribbean small states and Total Labor Force (in %) in Central Europe?
Your answer should be compact. 14.68. In the year 1998, what is the difference between the Total Labor Force (in %) in Caribbean small states and Total Labor Force (in %) in Lithuania?
Your answer should be compact. 7.39. In the year 1998, what is the difference between the Total Labor Force (in %) in Caribbean small states and Total Labor Force (in %) in Nigeria?
Offer a very short reply. 18.99. In the year 1998, what is the difference between the Total Labor Force (in %) of Central Europe and Total Labor Force (in %) of Lithuania?
Offer a very short reply. -7.29. In the year 1998, what is the difference between the Total Labor Force (in %) of Central Europe and Total Labor Force (in %) of Nigeria?
Offer a terse response. 4.31. In the year 1999, what is the difference between the Total Labor Force (in %) of Caribbean small states and Total Labor Force (in %) of Central Europe?
Your response must be concise. 16.14. In the year 1999, what is the difference between the Total Labor Force (in %) in Caribbean small states and Total Labor Force (in %) in Lithuania?
Make the answer very short. 10.92. In the year 1999, what is the difference between the Total Labor Force (in %) of Caribbean small states and Total Labor Force (in %) of Nigeria?
Ensure brevity in your answer.  18.42. In the year 1999, what is the difference between the Total Labor Force (in %) in Central Europe and Total Labor Force (in %) in Lithuania?
Your answer should be very brief. -5.22. In the year 1999, what is the difference between the Total Labor Force (in %) in Central Europe and Total Labor Force (in %) in Nigeria?
Provide a succinct answer. 2.28. In the year 1999, what is the difference between the Total Labor Force (in %) in Lithuania and Total Labor Force (in %) in Nigeria?
Your response must be concise. 7.5. In the year 2000, what is the difference between the Total Labor Force (in %) in Caribbean small states and Total Labor Force (in %) in Central Europe?
Your answer should be compact. 15.08. In the year 2000, what is the difference between the Total Labor Force (in %) of Caribbean small states and Total Labor Force (in %) of Lithuania?
Offer a terse response. 16.75. In the year 2000, what is the difference between the Total Labor Force (in %) in Caribbean small states and Total Labor Force (in %) in Nigeria?
Offer a terse response. 18.15. In the year 2000, what is the difference between the Total Labor Force (in %) in Central Europe and Total Labor Force (in %) in Lithuania?
Your answer should be very brief. 1.67. In the year 2000, what is the difference between the Total Labor Force (in %) of Central Europe and Total Labor Force (in %) of Nigeria?
Your answer should be very brief. 3.07. In the year 2000, what is the difference between the Total Labor Force (in %) of Lithuania and Total Labor Force (in %) of Nigeria?
Offer a terse response. 1.4. In the year 2001, what is the difference between the Total Labor Force (in %) of Caribbean small states and Total Labor Force (in %) of Central Europe?
Offer a terse response. 14.94. In the year 2001, what is the difference between the Total Labor Force (in %) in Caribbean small states and Total Labor Force (in %) in Lithuania?
Your response must be concise. 19.21. In the year 2001, what is the difference between the Total Labor Force (in %) in Caribbean small states and Total Labor Force (in %) in Nigeria?
Your answer should be compact. 17.31. In the year 2001, what is the difference between the Total Labor Force (in %) of Central Europe and Total Labor Force (in %) of Lithuania?
Provide a short and direct response. 4.27. In the year 2001, what is the difference between the Total Labor Force (in %) of Central Europe and Total Labor Force (in %) of Nigeria?
Provide a short and direct response. 2.37. In the year 2001, what is the difference between the Total Labor Force (in %) of Lithuania and Total Labor Force (in %) of Nigeria?
Give a very brief answer. -1.9. In the year 2002, what is the difference between the Total Labor Force (in %) of Caribbean small states and Total Labor Force (in %) of Central Europe?
Give a very brief answer. 15.92. In the year 2002, what is the difference between the Total Labor Force (in %) of Caribbean small states and Total Labor Force (in %) of Lithuania?
Provide a succinct answer. 20.04. In the year 2002, what is the difference between the Total Labor Force (in %) of Caribbean small states and Total Labor Force (in %) of Nigeria?
Ensure brevity in your answer.  16.64. In the year 2002, what is the difference between the Total Labor Force (in %) of Central Europe and Total Labor Force (in %) of Lithuania?
Give a very brief answer. 4.12. In the year 2002, what is the difference between the Total Labor Force (in %) in Central Europe and Total Labor Force (in %) in Nigeria?
Provide a short and direct response. 0.72. In the year 2002, what is the difference between the Total Labor Force (in %) in Lithuania and Total Labor Force (in %) in Nigeria?
Your answer should be compact. -3.4. In the year 2003, what is the difference between the Total Labor Force (in %) in Caribbean small states and Total Labor Force (in %) in Central Europe?
Give a very brief answer. 17.06. In the year 2003, what is the difference between the Total Labor Force (in %) of Caribbean small states and Total Labor Force (in %) of Lithuania?
Your answer should be compact. 19.26. In the year 2003, what is the difference between the Total Labor Force (in %) in Caribbean small states and Total Labor Force (in %) in Nigeria?
Your answer should be compact. 16.56. In the year 2003, what is the difference between the Total Labor Force (in %) in Central Europe and Total Labor Force (in %) in Lithuania?
Offer a very short reply. 2.21. In the year 2003, what is the difference between the Total Labor Force (in %) in Central Europe and Total Labor Force (in %) in Nigeria?
Keep it short and to the point. -0.49. In the year 2003, what is the difference between the Total Labor Force (in %) of Lithuania and Total Labor Force (in %) of Nigeria?
Give a very brief answer. -2.7. In the year 2004, what is the difference between the Total Labor Force (in %) of Caribbean small states and Total Labor Force (in %) of Central Europe?
Ensure brevity in your answer.  17.15. In the year 2004, what is the difference between the Total Labor Force (in %) of Caribbean small states and Total Labor Force (in %) of Lithuania?
Your response must be concise. 21.84. In the year 2004, what is the difference between the Total Labor Force (in %) in Caribbean small states and Total Labor Force (in %) in Nigeria?
Provide a succinct answer. 16.44. In the year 2004, what is the difference between the Total Labor Force (in %) of Central Europe and Total Labor Force (in %) of Lithuania?
Give a very brief answer. 4.68. In the year 2004, what is the difference between the Total Labor Force (in %) of Central Europe and Total Labor Force (in %) of Nigeria?
Give a very brief answer. -0.72. In the year 2005, what is the difference between the Total Labor Force (in %) in Caribbean small states and Total Labor Force (in %) in Central Europe?
Give a very brief answer. 18.83. In the year 2005, what is the difference between the Total Labor Force (in %) of Caribbean small states and Total Labor Force (in %) of Lithuania?
Your response must be concise. 25.18. In the year 2005, what is the difference between the Total Labor Force (in %) of Caribbean small states and Total Labor Force (in %) of Nigeria?
Keep it short and to the point. 15.98. In the year 2005, what is the difference between the Total Labor Force (in %) in Central Europe and Total Labor Force (in %) in Lithuania?
Ensure brevity in your answer.  6.35. In the year 2005, what is the difference between the Total Labor Force (in %) in Central Europe and Total Labor Force (in %) in Nigeria?
Make the answer very short. -2.85. In the year 2005, what is the difference between the Total Labor Force (in %) of Lithuania and Total Labor Force (in %) of Nigeria?
Offer a terse response. -9.2. What is the ratio of the Total Labor Force (in %) in Caribbean small states in 1998 to that in 1999?
Give a very brief answer. 1.01. What is the ratio of the Total Labor Force (in %) in Central Europe in 1998 to that in 1999?
Keep it short and to the point. 1.05. What is the ratio of the Total Labor Force (in %) of Lithuania in 1998 to that in 1999?
Offer a very short reply. 1.09. What is the ratio of the Total Labor Force (in %) in Nigeria in 1998 to that in 1999?
Offer a very short reply. 1.01. What is the ratio of the Total Labor Force (in %) in Caribbean small states in 1998 to that in 2000?
Keep it short and to the point. 1.03. What is the ratio of the Total Labor Force (in %) of Central Europe in 1998 to that in 2000?
Offer a terse response. 1.04. What is the ratio of the Total Labor Force (in %) of Lithuania in 1998 to that in 2000?
Provide a succinct answer. 1.26. What is the ratio of the Total Labor Force (in %) in Nigeria in 1998 to that in 2000?
Provide a short and direct response. 1.02. What is the ratio of the Total Labor Force (in %) of Caribbean small states in 1998 to that in 2001?
Offer a terse response. 1.05. What is the ratio of the Total Labor Force (in %) of Central Europe in 1998 to that in 2001?
Make the answer very short. 1.07. What is the ratio of the Total Labor Force (in %) of Lithuania in 1998 to that in 2001?
Keep it short and to the point. 1.38. What is the ratio of the Total Labor Force (in %) of Nigeria in 1998 to that in 2001?
Give a very brief answer. 1.02. What is the ratio of the Total Labor Force (in %) of Caribbean small states in 1998 to that in 2002?
Provide a short and direct response. 1.07. What is the ratio of the Total Labor Force (in %) in Central Europe in 1998 to that in 2002?
Give a very brief answer. 1.12. What is the ratio of the Total Labor Force (in %) in Lithuania in 1998 to that in 2002?
Your answer should be very brief. 1.45. What is the ratio of the Total Labor Force (in %) of Nigeria in 1998 to that in 2002?
Make the answer very short. 1.04. What is the ratio of the Total Labor Force (in %) in Caribbean small states in 1998 to that in 2003?
Your answer should be very brief. 1.07. What is the ratio of the Total Labor Force (in %) of Central Europe in 1998 to that in 2003?
Your answer should be very brief. 1.17. What is the ratio of the Total Labor Force (in %) of Lithuania in 1998 to that in 2003?
Keep it short and to the point. 1.44. What is the ratio of the Total Labor Force (in %) in Nigeria in 1998 to that in 2003?
Ensure brevity in your answer.  1.04. What is the ratio of the Total Labor Force (in %) in Caribbean small states in 1998 to that in 2004?
Make the answer very short. 1.08. What is the ratio of the Total Labor Force (in %) of Central Europe in 1998 to that in 2004?
Offer a very short reply. 1.19. What is the ratio of the Total Labor Force (in %) in Lithuania in 1998 to that in 2004?
Give a very brief answer. 1.57. What is the ratio of the Total Labor Force (in %) in Nigeria in 1998 to that in 2004?
Offer a very short reply. 1.05. What is the ratio of the Total Labor Force (in %) of Caribbean small states in 1998 to that in 2005?
Give a very brief answer. 1.09. What is the ratio of the Total Labor Force (in %) of Central Europe in 1998 to that in 2005?
Ensure brevity in your answer.  1.25. What is the ratio of the Total Labor Force (in %) of Lithuania in 1998 to that in 2005?
Offer a very short reply. 1.76. What is the ratio of the Total Labor Force (in %) of Nigeria in 1998 to that in 2005?
Ensure brevity in your answer.  1.05. What is the ratio of the Total Labor Force (in %) of Caribbean small states in 1999 to that in 2000?
Provide a short and direct response. 1.01. What is the ratio of the Total Labor Force (in %) in Lithuania in 1999 to that in 2000?
Provide a succinct answer. 1.16. What is the ratio of the Total Labor Force (in %) in Nigeria in 1999 to that in 2000?
Provide a short and direct response. 1.01. What is the ratio of the Total Labor Force (in %) in Caribbean small states in 1999 to that in 2001?
Offer a terse response. 1.03. What is the ratio of the Total Labor Force (in %) of Central Europe in 1999 to that in 2001?
Make the answer very short. 1.01. What is the ratio of the Total Labor Force (in %) in Lithuania in 1999 to that in 2001?
Give a very brief answer. 1.26. What is the ratio of the Total Labor Force (in %) in Nigeria in 1999 to that in 2001?
Provide a short and direct response. 1.02. What is the ratio of the Total Labor Force (in %) in Caribbean small states in 1999 to that in 2002?
Your response must be concise. 1.05. What is the ratio of the Total Labor Force (in %) in Central Europe in 1999 to that in 2002?
Offer a terse response. 1.07. What is the ratio of the Total Labor Force (in %) in Lithuania in 1999 to that in 2002?
Your answer should be very brief. 1.33. What is the ratio of the Total Labor Force (in %) in Nigeria in 1999 to that in 2002?
Ensure brevity in your answer.  1.03. What is the ratio of the Total Labor Force (in %) in Caribbean small states in 1999 to that in 2003?
Make the answer very short. 1.06. What is the ratio of the Total Labor Force (in %) in Central Europe in 1999 to that in 2003?
Make the answer very short. 1.11. What is the ratio of the Total Labor Force (in %) of Lithuania in 1999 to that in 2003?
Ensure brevity in your answer.  1.32. What is the ratio of the Total Labor Force (in %) in Nigeria in 1999 to that in 2003?
Ensure brevity in your answer.  1.04. What is the ratio of the Total Labor Force (in %) in Caribbean small states in 1999 to that in 2004?
Your answer should be very brief. 1.07. What is the ratio of the Total Labor Force (in %) of Central Europe in 1999 to that in 2004?
Offer a terse response. 1.13. What is the ratio of the Total Labor Force (in %) in Lithuania in 1999 to that in 2004?
Provide a short and direct response. 1.44. What is the ratio of the Total Labor Force (in %) in Nigeria in 1999 to that in 2004?
Your response must be concise. 1.05. What is the ratio of the Total Labor Force (in %) of Caribbean small states in 1999 to that in 2005?
Ensure brevity in your answer.  1.07. What is the ratio of the Total Labor Force (in %) of Central Europe in 1999 to that in 2005?
Make the answer very short. 1.19. What is the ratio of the Total Labor Force (in %) in Lithuania in 1999 to that in 2005?
Provide a succinct answer. 1.61. What is the ratio of the Total Labor Force (in %) in Nigeria in 1999 to that in 2005?
Your answer should be very brief. 1.04. What is the ratio of the Total Labor Force (in %) of Caribbean small states in 2000 to that in 2001?
Make the answer very short. 1.02. What is the ratio of the Total Labor Force (in %) in Central Europe in 2000 to that in 2001?
Provide a short and direct response. 1.02. What is the ratio of the Total Labor Force (in %) in Lithuania in 2000 to that in 2001?
Make the answer very short. 1.09. What is the ratio of the Total Labor Force (in %) of Nigeria in 2000 to that in 2001?
Your answer should be compact. 1.01. What is the ratio of the Total Labor Force (in %) of Caribbean small states in 2000 to that in 2002?
Give a very brief answer. 1.04. What is the ratio of the Total Labor Force (in %) in Central Europe in 2000 to that in 2002?
Give a very brief answer. 1.08. What is the ratio of the Total Labor Force (in %) of Lithuania in 2000 to that in 2002?
Offer a very short reply. 1.15. What is the ratio of the Total Labor Force (in %) in Nigeria in 2000 to that in 2002?
Offer a terse response. 1.02. What is the ratio of the Total Labor Force (in %) of Caribbean small states in 2000 to that in 2003?
Offer a terse response. 1.05. What is the ratio of the Total Labor Force (in %) of Central Europe in 2000 to that in 2003?
Your response must be concise. 1.12. What is the ratio of the Total Labor Force (in %) of Lithuania in 2000 to that in 2003?
Your answer should be very brief. 1.14. What is the ratio of the Total Labor Force (in %) in Nigeria in 2000 to that in 2003?
Your response must be concise. 1.03. What is the ratio of the Total Labor Force (in %) of Caribbean small states in 2000 to that in 2004?
Offer a terse response. 1.06. What is the ratio of the Total Labor Force (in %) in Central Europe in 2000 to that in 2004?
Ensure brevity in your answer.  1.14. What is the ratio of the Total Labor Force (in %) in Lithuania in 2000 to that in 2004?
Offer a terse response. 1.24. What is the ratio of the Total Labor Force (in %) of Nigeria in 2000 to that in 2004?
Provide a short and direct response. 1.04. What is the ratio of the Total Labor Force (in %) of Caribbean small states in 2000 to that in 2005?
Keep it short and to the point. 1.06. What is the ratio of the Total Labor Force (in %) of Central Europe in 2000 to that in 2005?
Provide a succinct answer. 1.2. What is the ratio of the Total Labor Force (in %) of Lithuania in 2000 to that in 2005?
Offer a terse response. 1.39. What is the ratio of the Total Labor Force (in %) in Nigeria in 2000 to that in 2005?
Your response must be concise. 1.03. What is the ratio of the Total Labor Force (in %) of Caribbean small states in 2001 to that in 2002?
Your answer should be very brief. 1.02. What is the ratio of the Total Labor Force (in %) in Central Europe in 2001 to that in 2002?
Ensure brevity in your answer.  1.05. What is the ratio of the Total Labor Force (in %) in Lithuania in 2001 to that in 2002?
Give a very brief answer. 1.05. What is the ratio of the Total Labor Force (in %) in Caribbean small states in 2001 to that in 2003?
Give a very brief answer. 1.03. What is the ratio of the Total Labor Force (in %) in Central Europe in 2001 to that in 2003?
Your answer should be very brief. 1.09. What is the ratio of the Total Labor Force (in %) in Lithuania in 2001 to that in 2003?
Ensure brevity in your answer.  1.04. What is the ratio of the Total Labor Force (in %) of Nigeria in 2001 to that in 2003?
Make the answer very short. 1.02. What is the ratio of the Total Labor Force (in %) of Caribbean small states in 2001 to that in 2004?
Your answer should be compact. 1.04. What is the ratio of the Total Labor Force (in %) of Central Europe in 2001 to that in 2004?
Your answer should be very brief. 1.11. What is the ratio of the Total Labor Force (in %) in Lithuania in 2001 to that in 2004?
Offer a terse response. 1.14. What is the ratio of the Total Labor Force (in %) of Nigeria in 2001 to that in 2004?
Your answer should be very brief. 1.03. What is the ratio of the Total Labor Force (in %) of Caribbean small states in 2001 to that in 2005?
Provide a short and direct response. 1.04. What is the ratio of the Total Labor Force (in %) of Central Europe in 2001 to that in 2005?
Make the answer very short. 1.17. What is the ratio of the Total Labor Force (in %) in Lithuania in 2001 to that in 2005?
Your answer should be compact. 1.27. What is the ratio of the Total Labor Force (in %) in Caribbean small states in 2002 to that in 2003?
Your answer should be very brief. 1.01. What is the ratio of the Total Labor Force (in %) of Central Europe in 2002 to that in 2003?
Offer a terse response. 1.04. What is the ratio of the Total Labor Force (in %) in Lithuania in 2002 to that in 2003?
Offer a terse response. 0.99. What is the ratio of the Total Labor Force (in %) of Nigeria in 2002 to that in 2003?
Provide a short and direct response. 1.01. What is the ratio of the Total Labor Force (in %) of Caribbean small states in 2002 to that in 2004?
Keep it short and to the point. 1.02. What is the ratio of the Total Labor Force (in %) in Central Europe in 2002 to that in 2004?
Offer a very short reply. 1.06. What is the ratio of the Total Labor Force (in %) of Lithuania in 2002 to that in 2004?
Your answer should be compact. 1.08. What is the ratio of the Total Labor Force (in %) in Nigeria in 2002 to that in 2004?
Your response must be concise. 1.02. What is the ratio of the Total Labor Force (in %) in Caribbean small states in 2002 to that in 2005?
Your response must be concise. 1.02. What is the ratio of the Total Labor Force (in %) of Central Europe in 2002 to that in 2005?
Keep it short and to the point. 1.11. What is the ratio of the Total Labor Force (in %) in Lithuania in 2002 to that in 2005?
Give a very brief answer. 1.21. What is the ratio of the Total Labor Force (in %) in Nigeria in 2002 to that in 2005?
Offer a very short reply. 1.01. What is the ratio of the Total Labor Force (in %) of Caribbean small states in 2003 to that in 2004?
Ensure brevity in your answer.  1.01. What is the ratio of the Total Labor Force (in %) of Central Europe in 2003 to that in 2004?
Ensure brevity in your answer.  1.02. What is the ratio of the Total Labor Force (in %) in Lithuania in 2003 to that in 2004?
Offer a very short reply. 1.09. What is the ratio of the Total Labor Force (in %) of Nigeria in 2003 to that in 2004?
Provide a short and direct response. 1.01. What is the ratio of the Total Labor Force (in %) of Caribbean small states in 2003 to that in 2005?
Provide a succinct answer. 1.01. What is the ratio of the Total Labor Force (in %) of Central Europe in 2003 to that in 2005?
Your answer should be compact. 1.07. What is the ratio of the Total Labor Force (in %) of Lithuania in 2003 to that in 2005?
Your answer should be very brief. 1.22. What is the ratio of the Total Labor Force (in %) in Nigeria in 2003 to that in 2005?
Ensure brevity in your answer.  1.01. What is the ratio of the Total Labor Force (in %) in Caribbean small states in 2004 to that in 2005?
Offer a very short reply. 1. What is the ratio of the Total Labor Force (in %) in Central Europe in 2004 to that in 2005?
Make the answer very short. 1.05. What is the ratio of the Total Labor Force (in %) of Lithuania in 2004 to that in 2005?
Keep it short and to the point. 1.12. What is the difference between the highest and the second highest Total Labor Force (in %) of Caribbean small states?
Provide a succinct answer. 0.87. What is the difference between the highest and the second highest Total Labor Force (in %) of Central Europe?
Offer a very short reply. 1.93. What is the difference between the highest and the second highest Total Labor Force (in %) of Lithuania?
Your response must be concise. 4.4. What is the difference between the highest and the lowest Total Labor Force (in %) in Caribbean small states?
Provide a short and direct response. 4.9. What is the difference between the highest and the lowest Total Labor Force (in %) of Central Europe?
Offer a terse response. 9.05. What is the difference between the highest and the lowest Total Labor Force (in %) of Lithuania?
Provide a succinct answer. 22.7. 